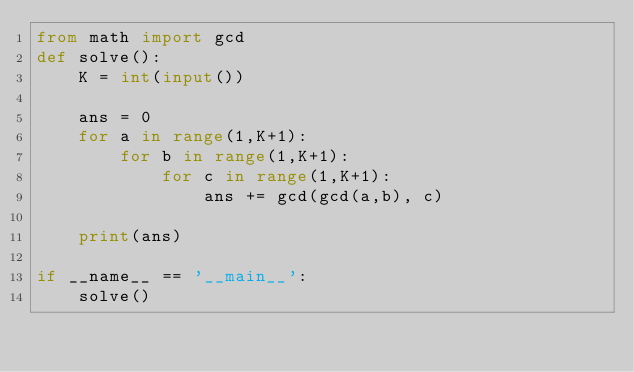Convert code to text. <code><loc_0><loc_0><loc_500><loc_500><_Python_>from math import gcd
def solve():
    K = int(input())

    ans = 0
    for a in range(1,K+1):
        for b in range(1,K+1):
            for c in range(1,K+1):
                ans += gcd(gcd(a,b), c)
    
    print(ans)

if __name__ == '__main__':
    solve()</code> 